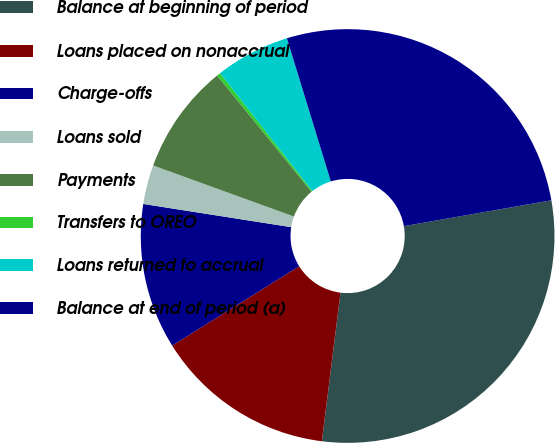<chart> <loc_0><loc_0><loc_500><loc_500><pie_chart><fcel>Balance at beginning of period<fcel>Loans placed on nonaccrual<fcel>Charge-offs<fcel>Loans sold<fcel>Payments<fcel>Transfers to OREO<fcel>Loans returned to accrual<fcel>Balance at end of period (a)<nl><fcel>29.75%<fcel>14.13%<fcel>11.36%<fcel>3.06%<fcel>8.6%<fcel>0.29%<fcel>5.83%<fcel>26.98%<nl></chart> 